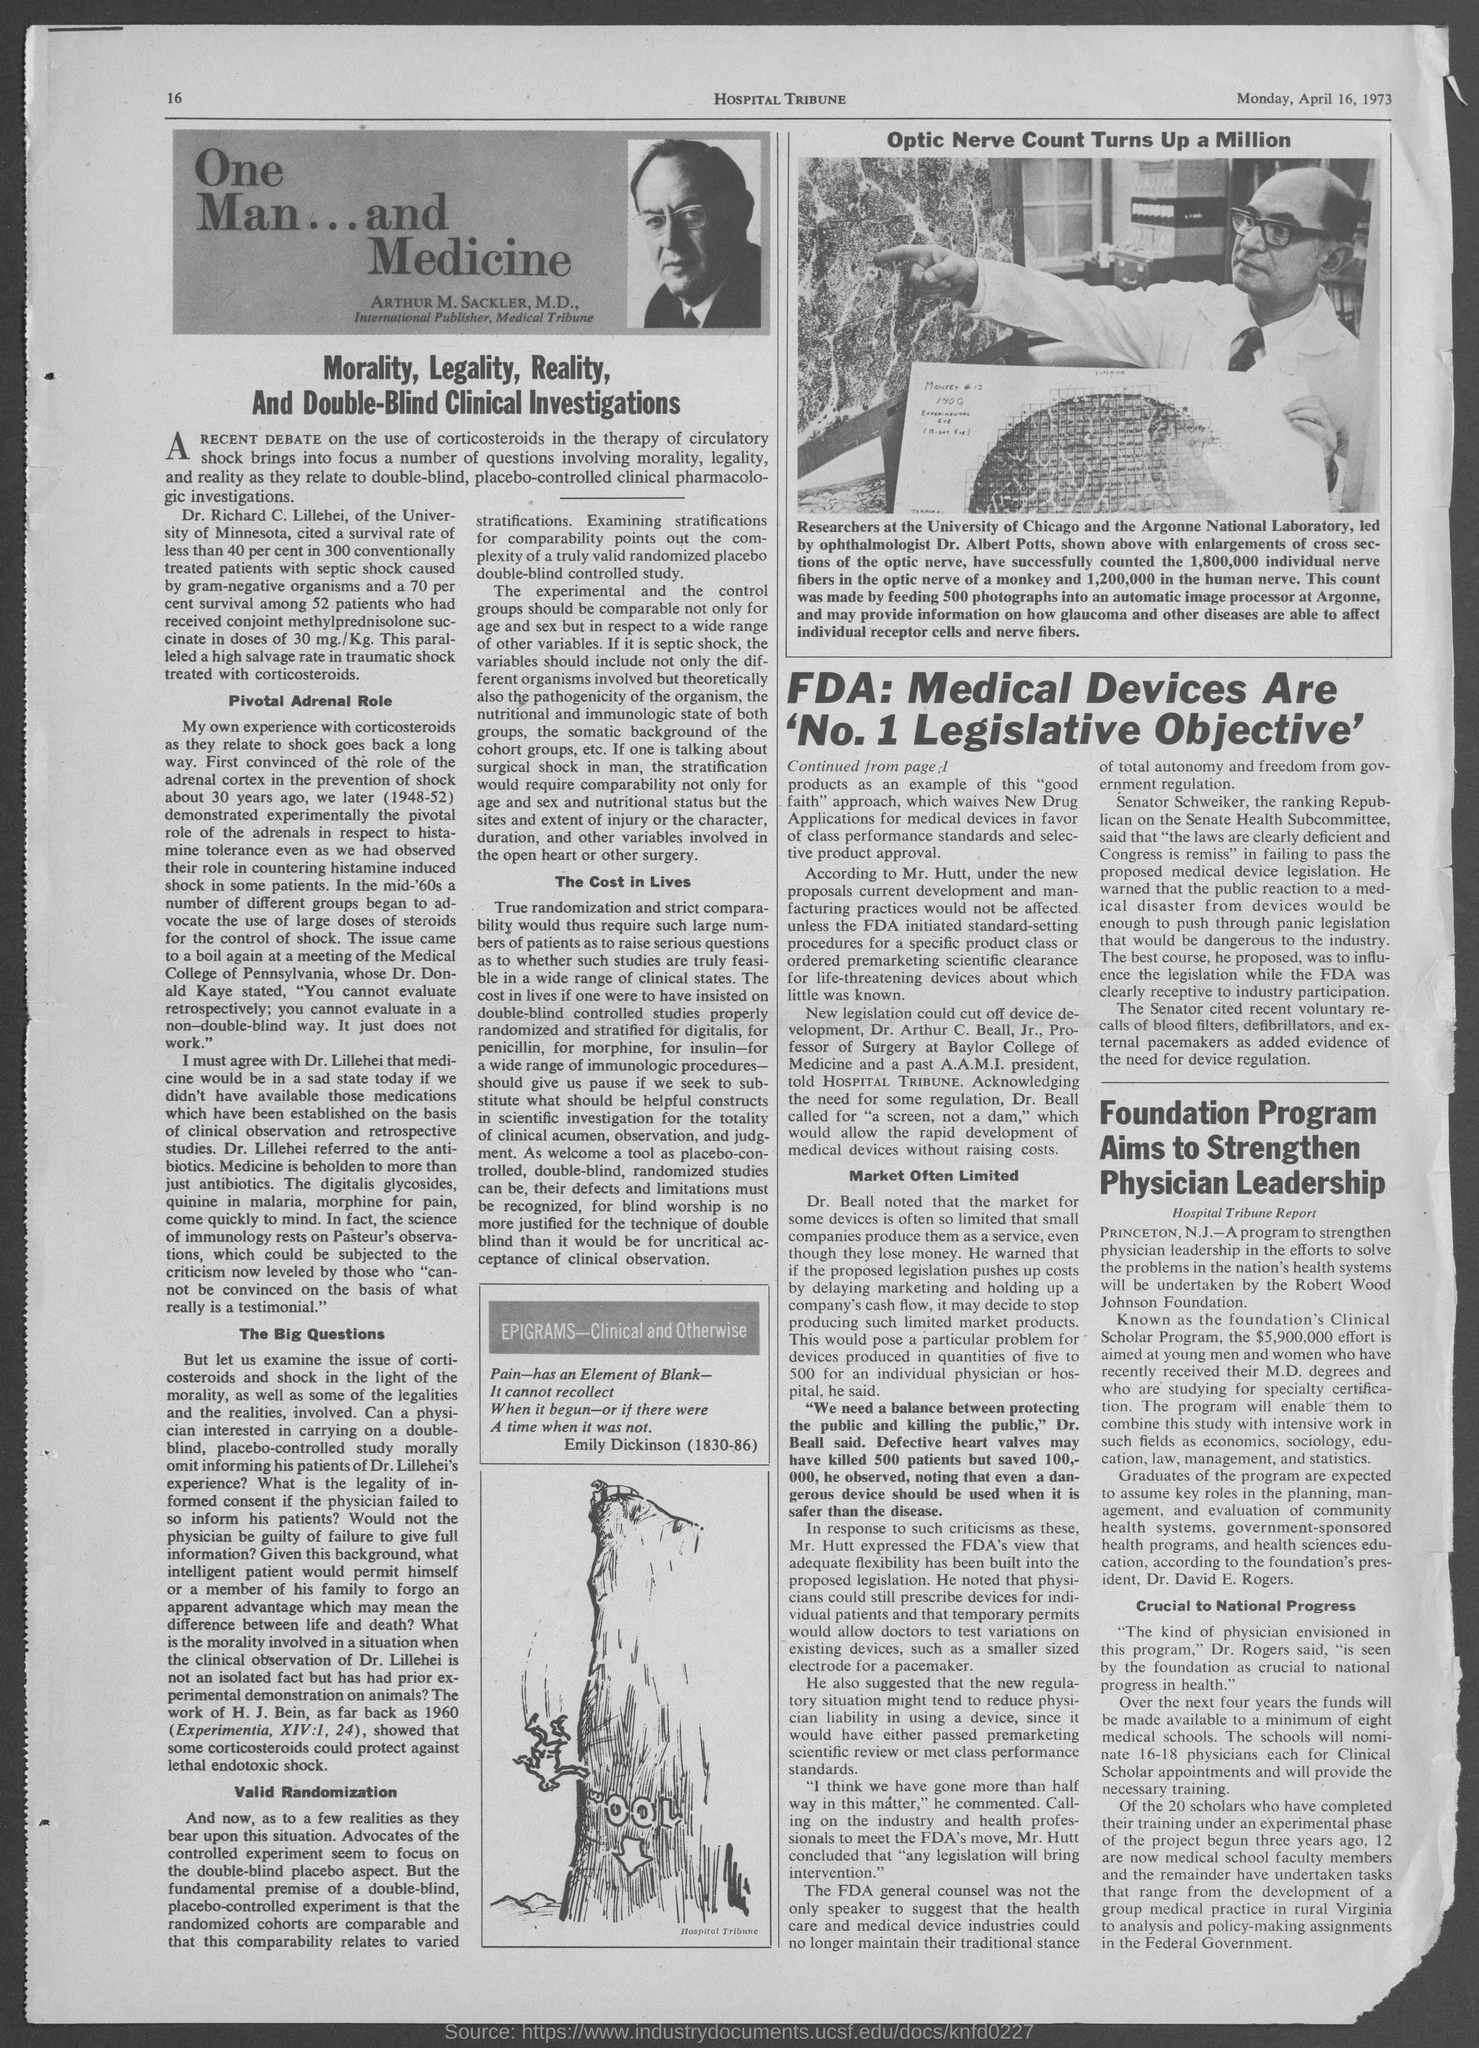Which is the paper?
Your answer should be very brief. Hospital Tribune. 